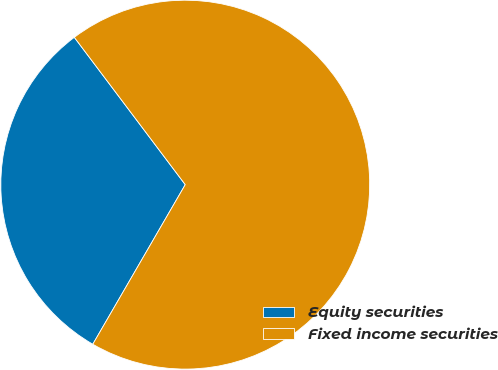<chart> <loc_0><loc_0><loc_500><loc_500><pie_chart><fcel>Equity securities<fcel>Fixed income securities<nl><fcel>31.37%<fcel>68.63%<nl></chart> 